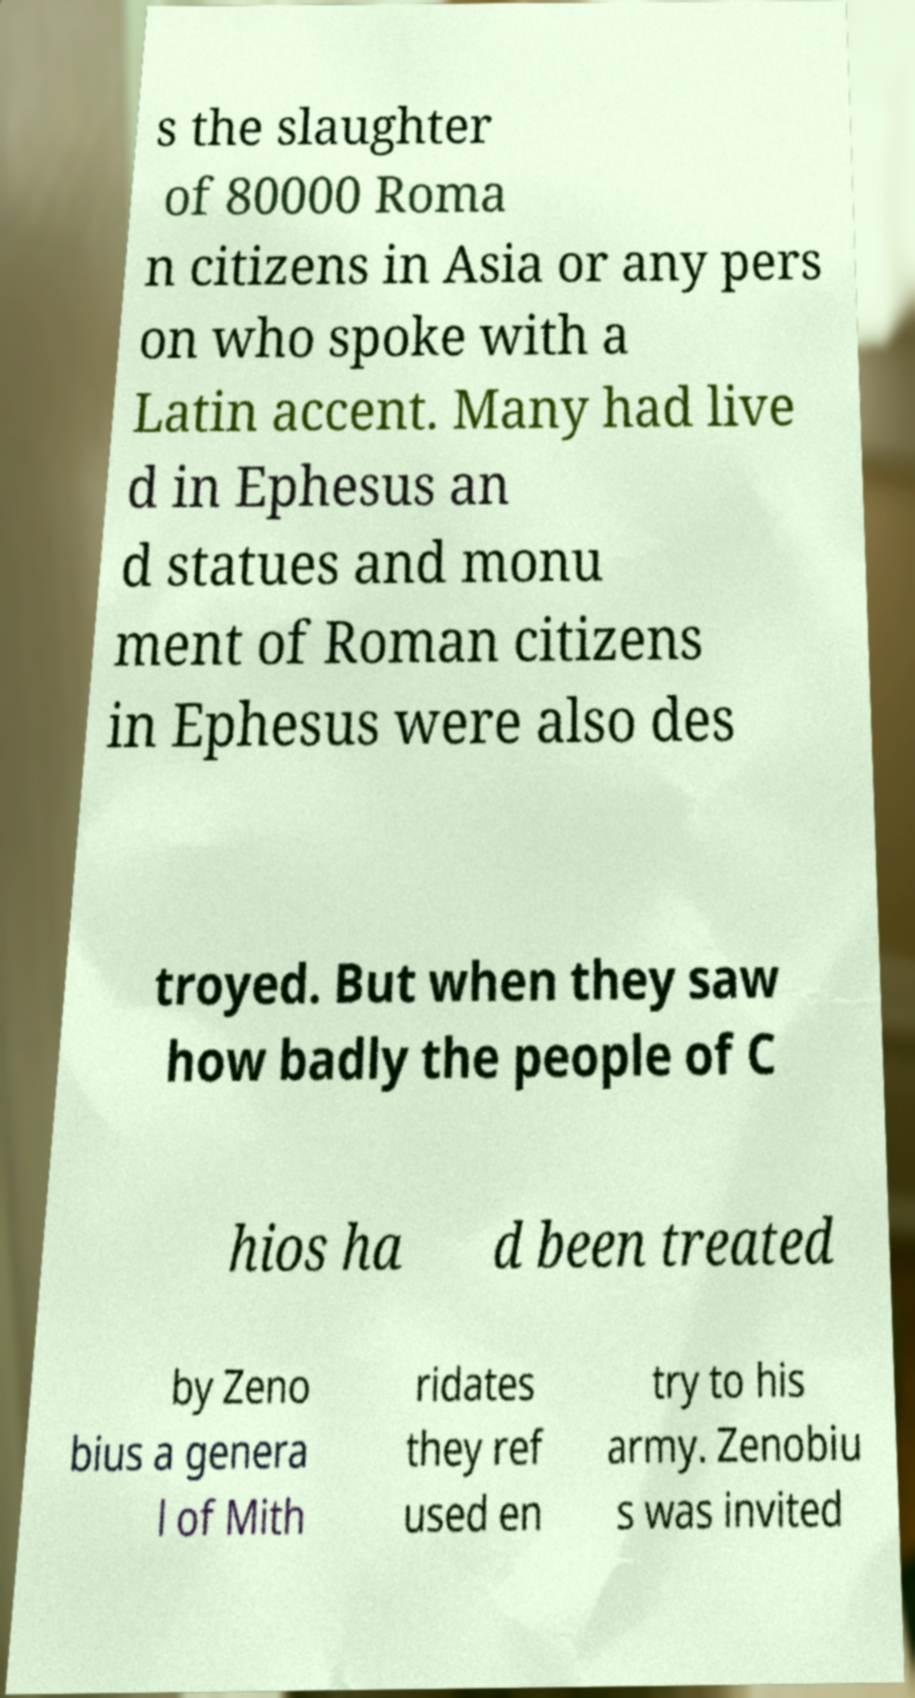I need the written content from this picture converted into text. Can you do that? s the slaughter of 80000 Roma n citizens in Asia or any pers on who spoke with a Latin accent. Many had live d in Ephesus an d statues and monu ment of Roman citizens in Ephesus were also des troyed. But when they saw how badly the people of C hios ha d been treated by Zeno bius a genera l of Mith ridates they ref used en try to his army. Zenobiu s was invited 